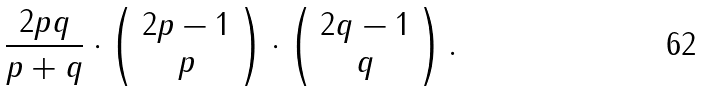Convert formula to latex. <formula><loc_0><loc_0><loc_500><loc_500>\frac { 2 p q } { p + q } \cdot \left ( \begin{array} { c } 2 p - 1 \\ p \end{array} \right ) \cdot \left ( \begin{array} { c } 2 q - 1 \\ q \end{array} \right ) .</formula> 